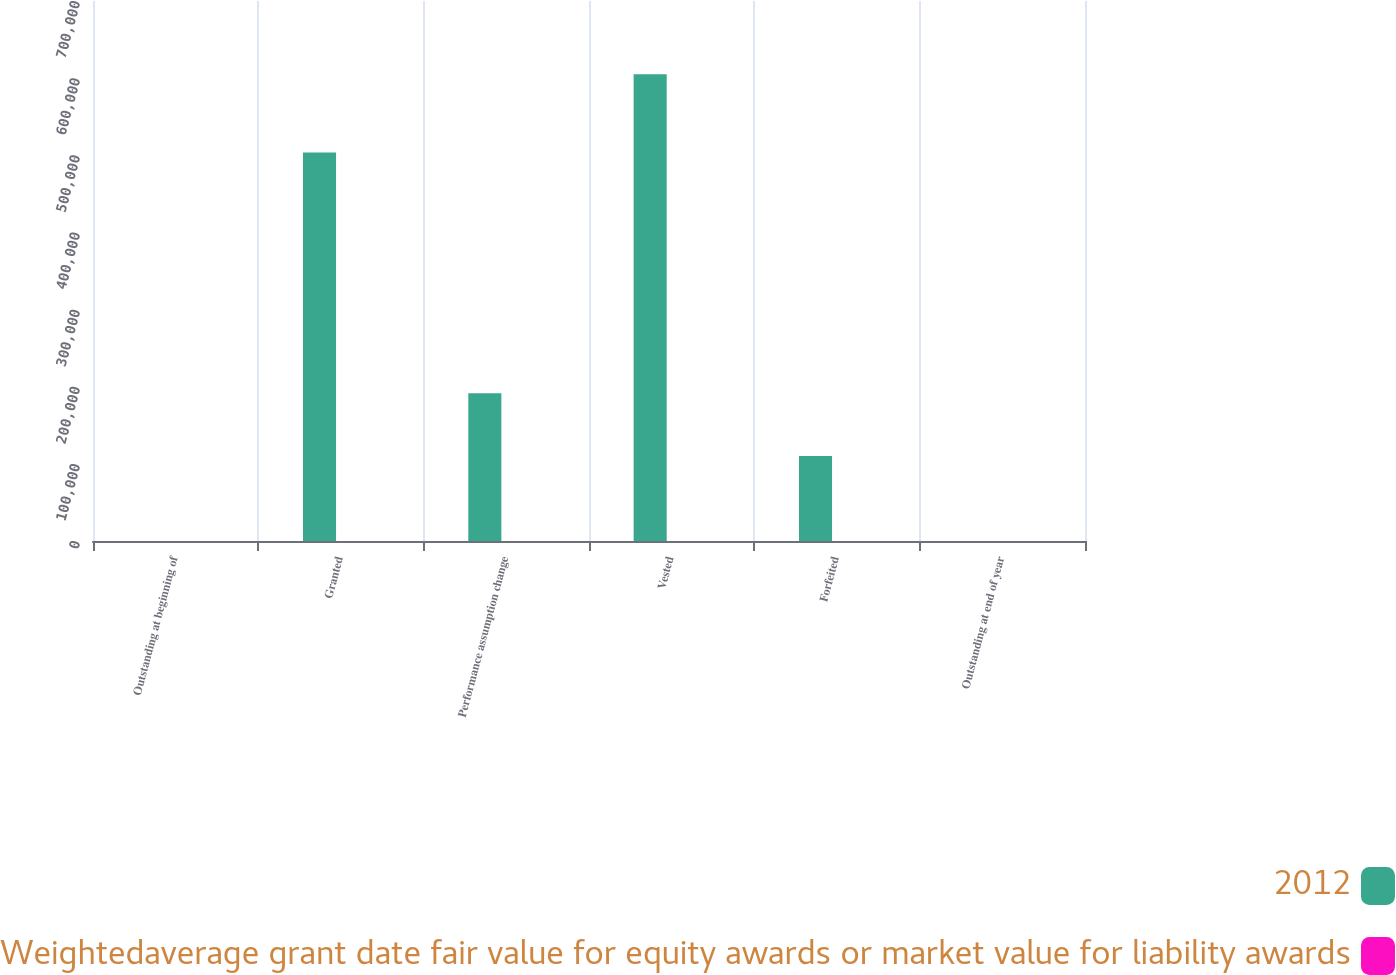<chart> <loc_0><loc_0><loc_500><loc_500><stacked_bar_chart><ecel><fcel>Outstanding at beginning of<fcel>Granted<fcel>Performance assumption change<fcel>Vested<fcel>Forfeited<fcel>Outstanding at end of year<nl><fcel>2012<fcel>62.035<fcel>503761<fcel>191608<fcel>605208<fcel>110063<fcel>62.035<nl><fcel>Weightedaverage grant date fair value for equity awards or market value for liability awards<fcel>48.7<fcel>64.99<fcel>59.08<fcel>43.14<fcel>58.13<fcel>56.71<nl></chart> 